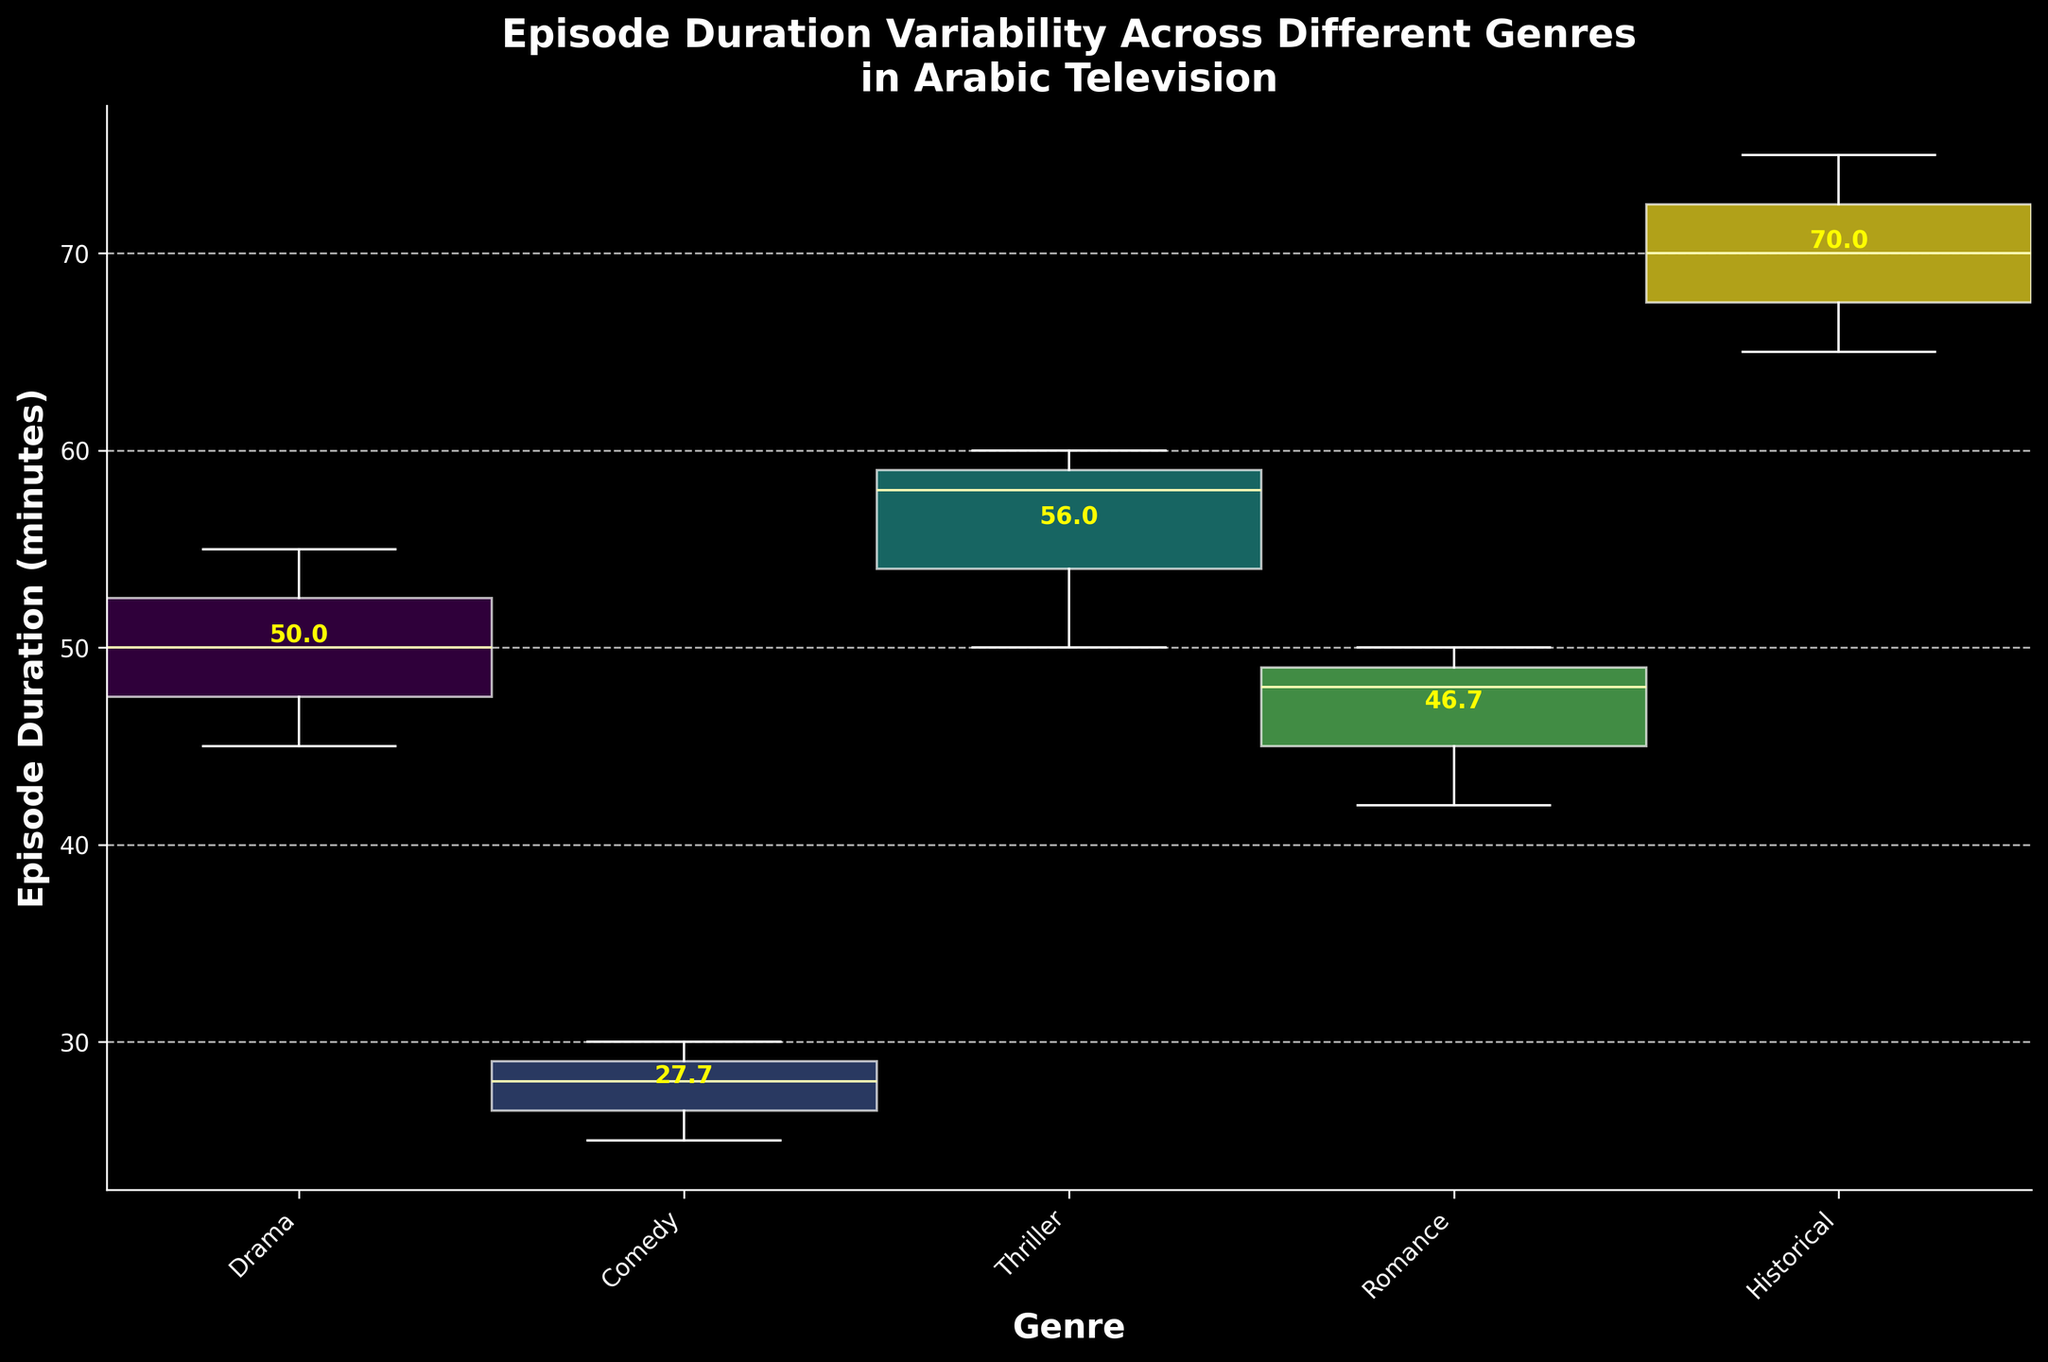Which genre has the highest median episode duration? To determine the genre with the highest median episode duration, we examine the line in the middle of each box plot representing the median. The Historical genre has the highest median duration.
Answer: Historical What are the axis labels in the plot? The x-axis represents different genres, while the y-axis indicates episode duration in minutes.
Answer: x-axis: Genre, y-axis: Episode Duration (minutes) How does the variability in episode durations for the Drama genre compare to the Comedy genre? By looking at the spread of the box plots for Drama and Comedy, Drama has a larger interquartile range and longer whiskers indicating more variability compared to Comedy.
Answer: Drama has more variability What's the average episode duration for the Thriller genre as indicated in the plot? The mean episode duration value is annotated above the box for the Thriller genre. Looking at the text on the plot, it shows approximately 56.0 minutes.
Answer: 56.0 What genre has the smallest width in the box plot, and what does this imply? The genre width represents the total number of episodes relative to other genres. The Historical genre has the smallest width, implying it has fewer episodes compared to other genres.
Answer: Historical Which genre shows the most consistency (least variability) in episode durations? The Comedy genre has the smallest interquartile range (IQR) and shortest whiskers, indicating the least variability and most consistency in episode durations.
Answer: Comedy What is the median episode duration for the Romance genre? The middle line in the box plot for the Romance genre indicates the median. Observing the plot, the median episode duration is approximately 48 minutes.
Answer: 48 Which genre appears to have the most varied episode duration range? The Historical genre box plot shows the widest range from the minimum to the maximum whisker, suggesting the most varied episode durations.
Answer: Historical Which genre has the lowest average episode duration? By reading the annotated means above the boxes, the Comedy genre, with 27.7 minutes, has the lowest average episode duration.
Answer: Comedy What does the width of each box plot represent in this context? The width of each box plot is proportional to the total number of episodes in each genre. Wider plots indicate higher total episode counts.
Answer: Total number of episodes per genre 